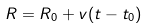<formula> <loc_0><loc_0><loc_500><loc_500>R = R _ { 0 } + v ( t - t _ { 0 } )</formula> 